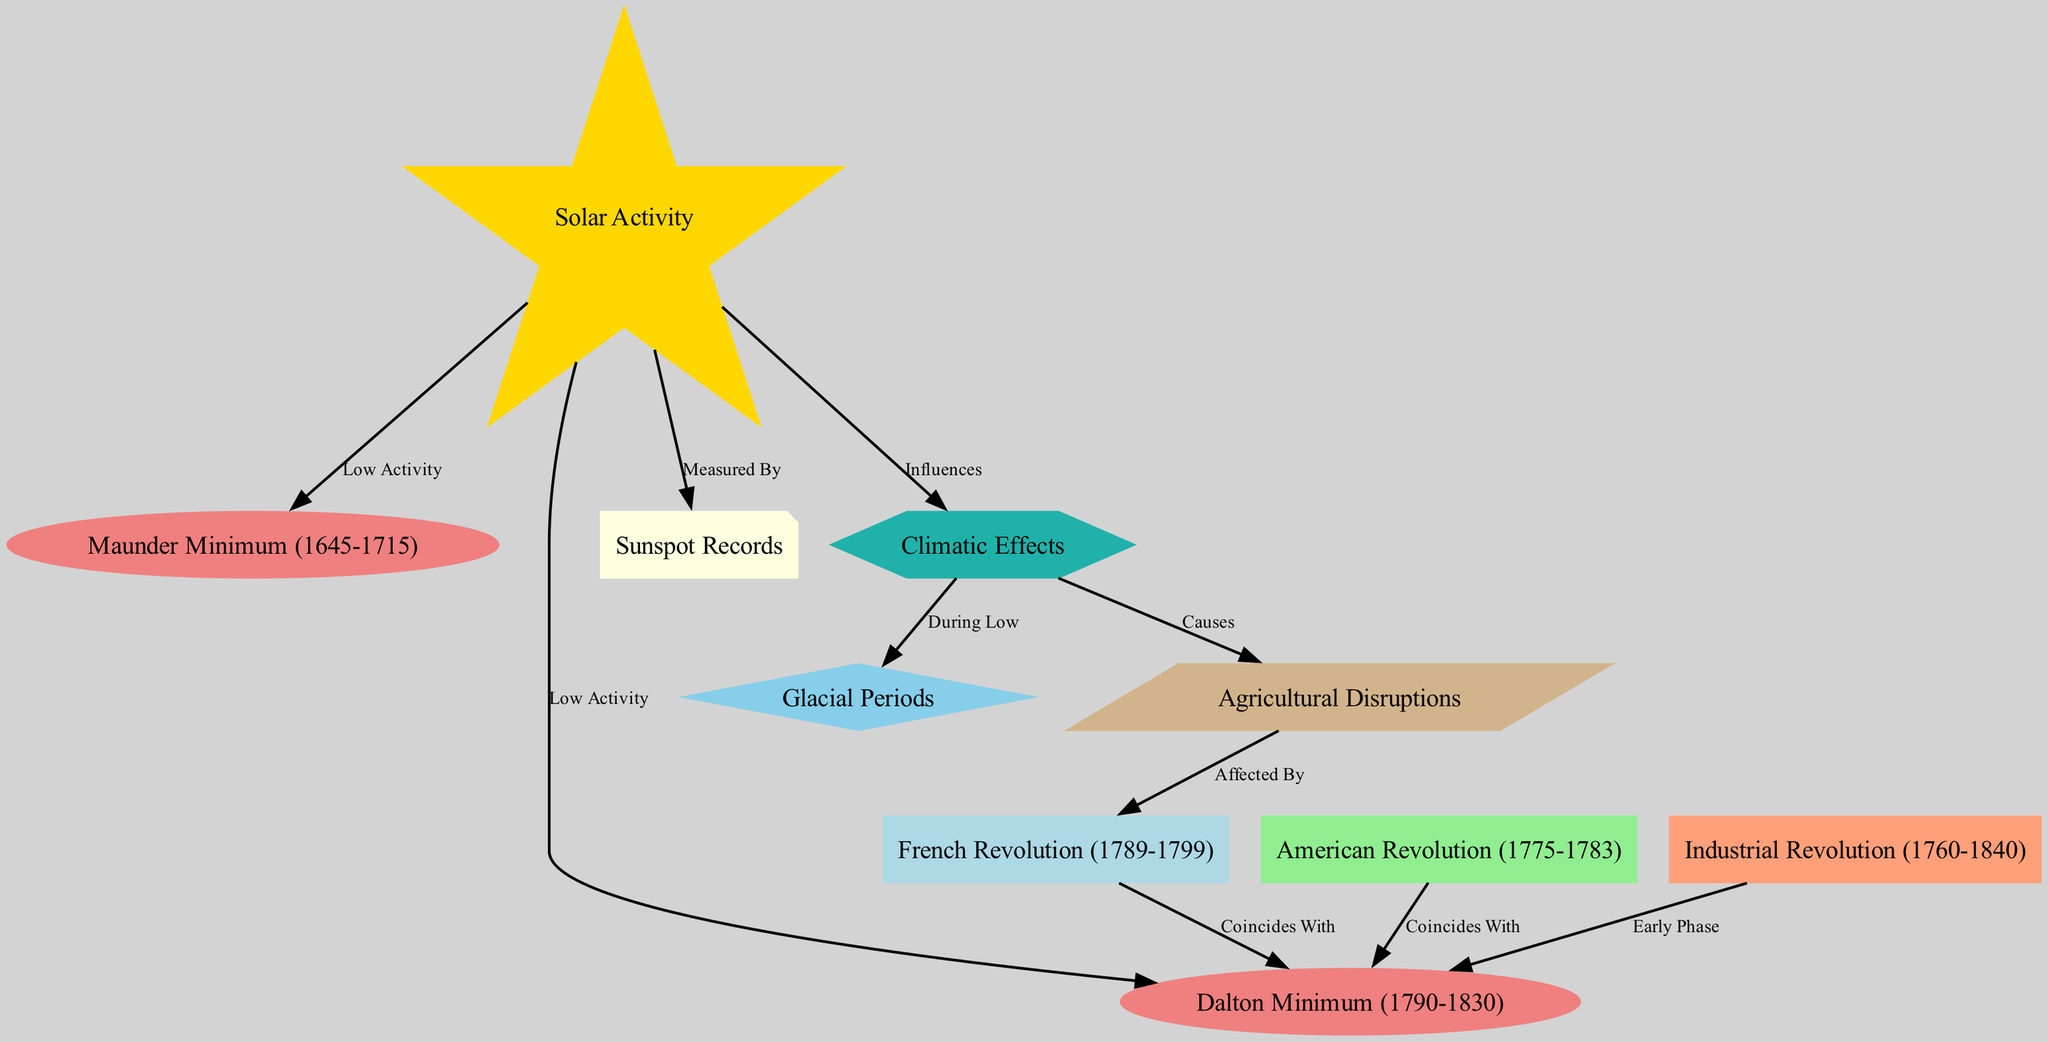What is the central node in the diagram? The diagram centers around "Solar Activity," which acts as a key point connecting to various historical events and phenomena.
Answer: Solar Activity How many nodes are present in the diagram? By counting the distinct items listed as nodes, we find there are a total of 10 nodes in the diagram.
Answer: 10 Which two historical events coincide with the Dalton Minimum? Both the "French Revolution" and the "American Revolution" are shown to coincide with the "Dalton Minimum," according to the edges connecting these nodes.
Answer: French Revolution, American Revolution What effect does solar activity have on climatic effects? The diagram indicates that "Solar Activity" influences "Climatic Effects," establishing a direct relationship between these two concepts.
Answer: Influences What are the consequences of climatic effects as shown in the diagram? The diagram illustrates that "Climatic Effects" cause "Agricultural Disruptions," leading to major impacts specifically in agriculture.
Answer: Causes What are the two historical revolutions affected by agricultural disruptions? "Agricultural Disruptions" are shown as a factor that affected the "French Revolution," therefore impacting its occurrence and progression.
Answer: French Revolution Which solar activity period is marked by low activity during the historical revolutions? The "Dalton Minimum" is highlighted as a period of low solar activity that directly coincides with significant historical events such as revolutions and economic changes.
Answer: Dalton Minimum Which periods are classified as glacial periods in relation to climatic effects? The diagram specifies that "Glacial Periods" occur during times categorized as low solar activity, suggesting a correlation between these two phenomena.
Answer: Glacial Periods 